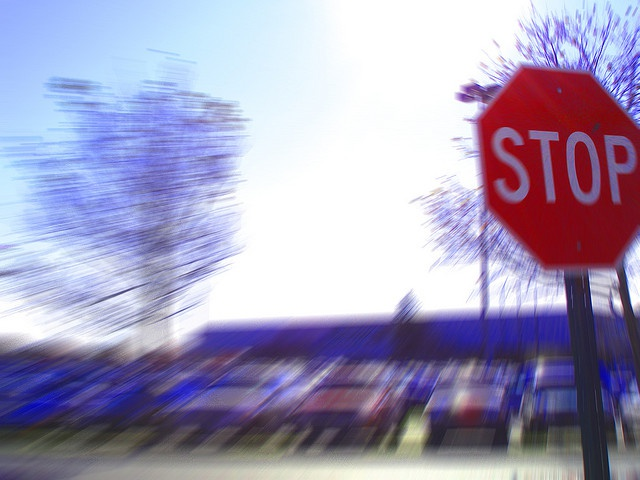Describe the objects in this image and their specific colors. I can see stop sign in lightblue, maroon, purple, and gray tones, car in lightblue, purple, black, and navy tones, car in lightblue, purple, and navy tones, car in lightblue, black, navy, blue, and gray tones, and car in lightblue, purple, and navy tones in this image. 